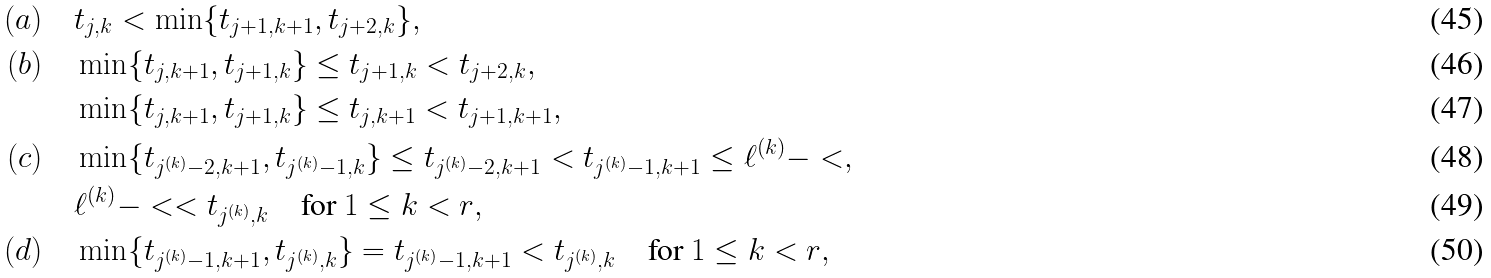Convert formula to latex. <formula><loc_0><loc_0><loc_500><loc_500>( a ) \quad & t _ { j , k } < \min \{ t _ { j + 1 , k + 1 } , t _ { j + 2 , k } \} , \\ ( b ) \quad & \min \{ t _ { j , k + 1 } , t _ { j + 1 , k } \} \leq t _ { j + 1 , k } < t _ { j + 2 , k } , \\ \quad & \min \{ t _ { j , k + 1 } , t _ { j + 1 , k } \} \leq t _ { j , k + 1 } < t _ { j + 1 , k + 1 } , \\ ( c ) \quad & \min \{ t _ { j ^ { ( k ) } - 2 , k + 1 } , t _ { j ^ { ( k ) } - 1 , k } \} \leq t _ { j ^ { ( k ) } - 2 , k + 1 } < t _ { j ^ { ( k ) } - 1 , k + 1 } \leq \ell ^ { ( k ) } - < , \\ \quad & \ell ^ { ( k ) } - < < t _ { j ^ { ( k ) } , k } \quad \text {for $1\leq k<r$} , \\ ( d ) \quad & \min \{ t _ { j ^ { ( k ) } - 1 , k + 1 } , t _ { j ^ { ( k ) } , k } \} = t _ { j ^ { ( k ) } - 1 , k + 1 } < t _ { j ^ { ( k ) } , k } \quad \text {for $1\leq k<r$} ,</formula> 